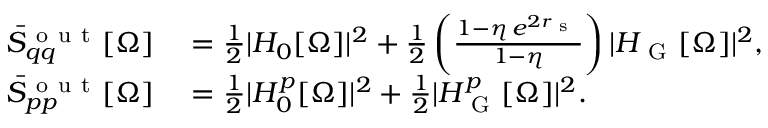Convert formula to latex. <formula><loc_0><loc_0><loc_500><loc_500>\begin{array} { r l } { \bar { S } _ { q q } ^ { o u t } [ \Omega ] } & = \frac { 1 } { 2 } | H _ { 0 } [ \Omega ] | ^ { 2 } + \frac { 1 } { 2 } \left ( \frac { 1 - \eta \, e ^ { 2 r _ { s } } } { 1 - \eta } \right ) | H _ { G } [ \Omega ] | ^ { 2 } , } \\ { \bar { S } _ { p p } ^ { o u t } [ \Omega ] } & = \frac { 1 } { 2 } | H _ { 0 } ^ { p } [ \Omega ] | ^ { 2 } + \frac { 1 } { 2 } | H _ { G } ^ { p } [ \Omega ] | ^ { 2 } . } \end{array}</formula> 